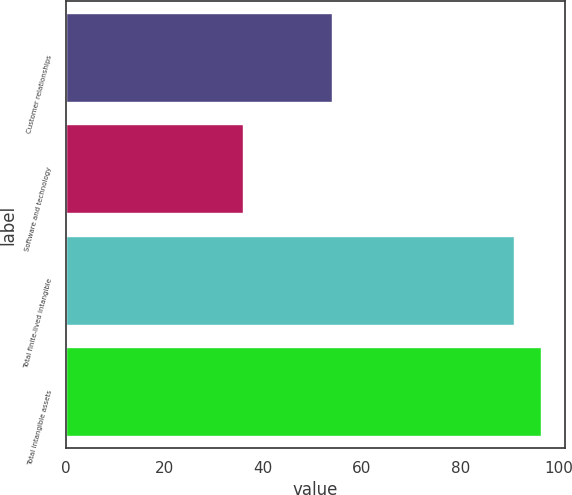<chart> <loc_0><loc_0><loc_500><loc_500><bar_chart><fcel>Customer relationships<fcel>Software and technology<fcel>Total finite-lived intangible<fcel>Total intangible assets<nl><fcel>54<fcel>36<fcel>91<fcel>96.5<nl></chart> 